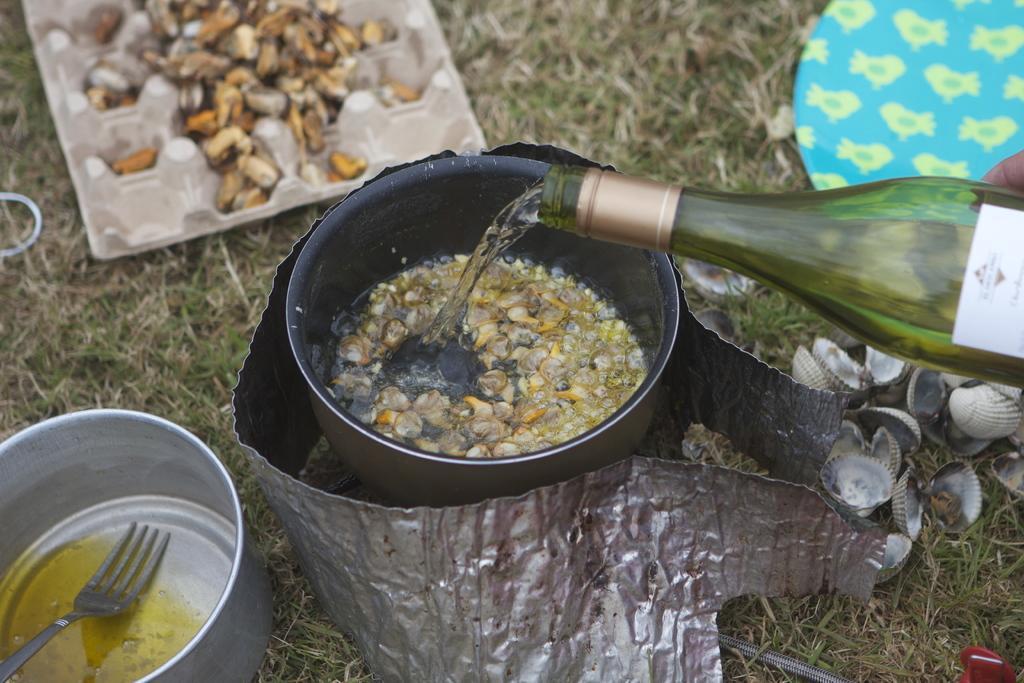In one or two sentences, can you explain what this image depicts? In the center of the image we can see a vessel containing food. On the left there is a bowl and a fork. On the right there is a bottle and we can see shells. There are plates and trays. At the bottom there is grass. 